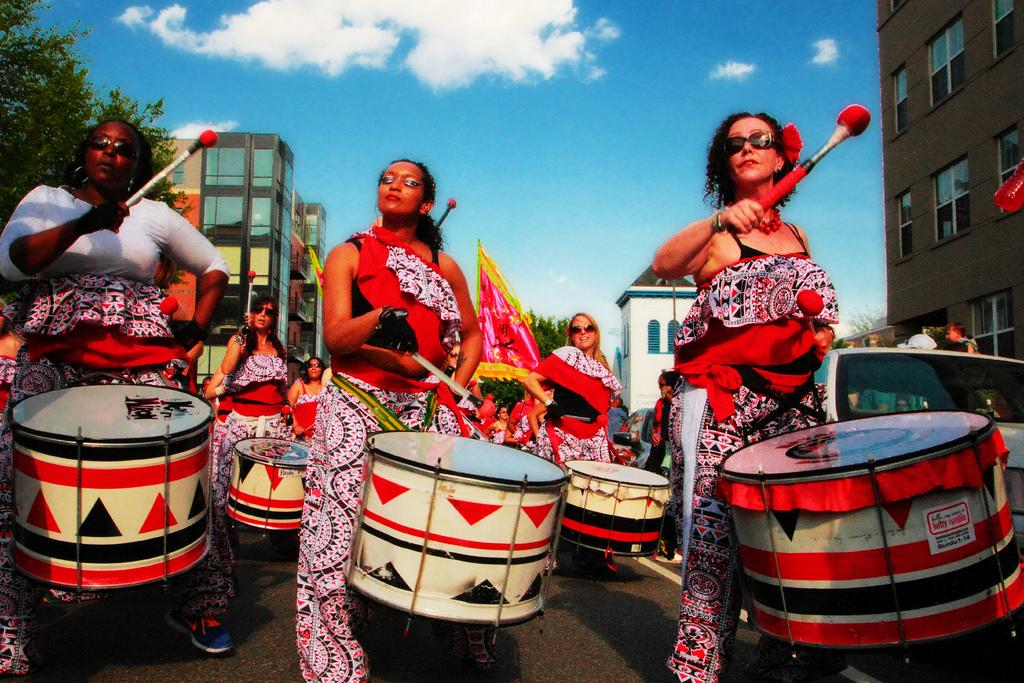What is happening in the image involving a group of women? The women are playing drums in the image. Can you describe the surroundings in the image? There are buildings on either side of the road in the image. Where is the mom of the women in the image? There is no reference to a mom in the image, so it is not possible to determine her location. What type of geese can be seen in the image? There are no geese present in the image. 